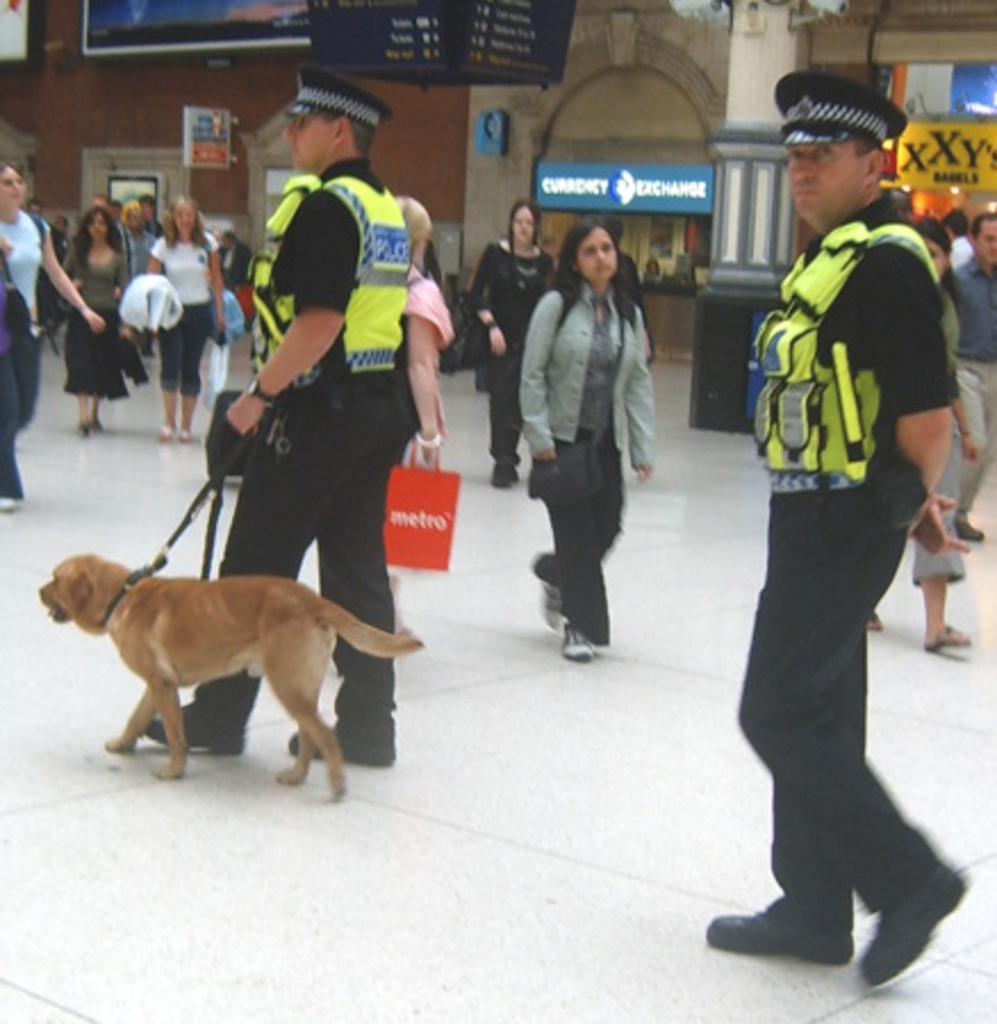Could you give a brief overview of what you see in this image? In this picture we can see persons walking on the floor. Here we can see two policemen. This man is holding dogs belt in his hand. These are pillars. Here we can see hoardings. 